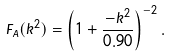<formula> <loc_0><loc_0><loc_500><loc_500>F _ { A } ( k ^ { 2 } ) = \left ( 1 + \frac { - k ^ { 2 } } { 0 . 9 0 } \right ) ^ { - 2 } .</formula> 